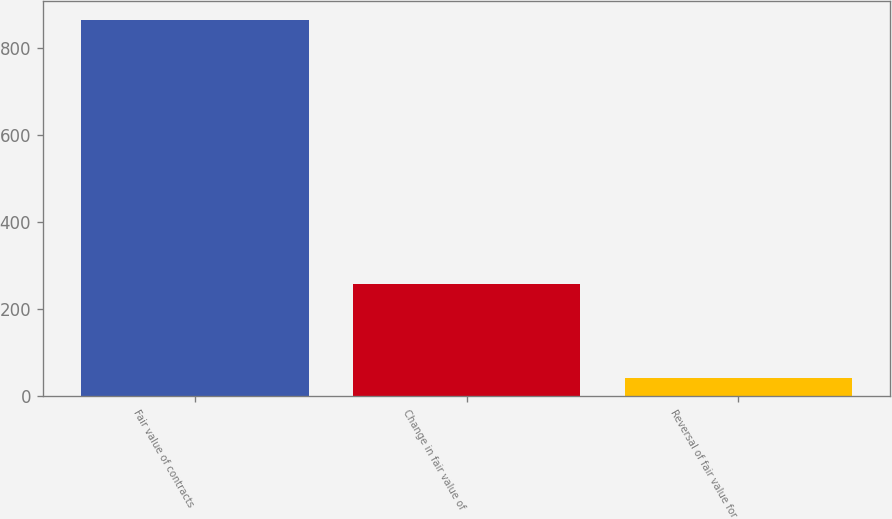Convert chart to OTSL. <chart><loc_0><loc_0><loc_500><loc_500><bar_chart><fcel>Fair value of contracts<fcel>Change in fair value of<fcel>Reversal of fair value for<nl><fcel>864<fcel>257<fcel>42<nl></chart> 